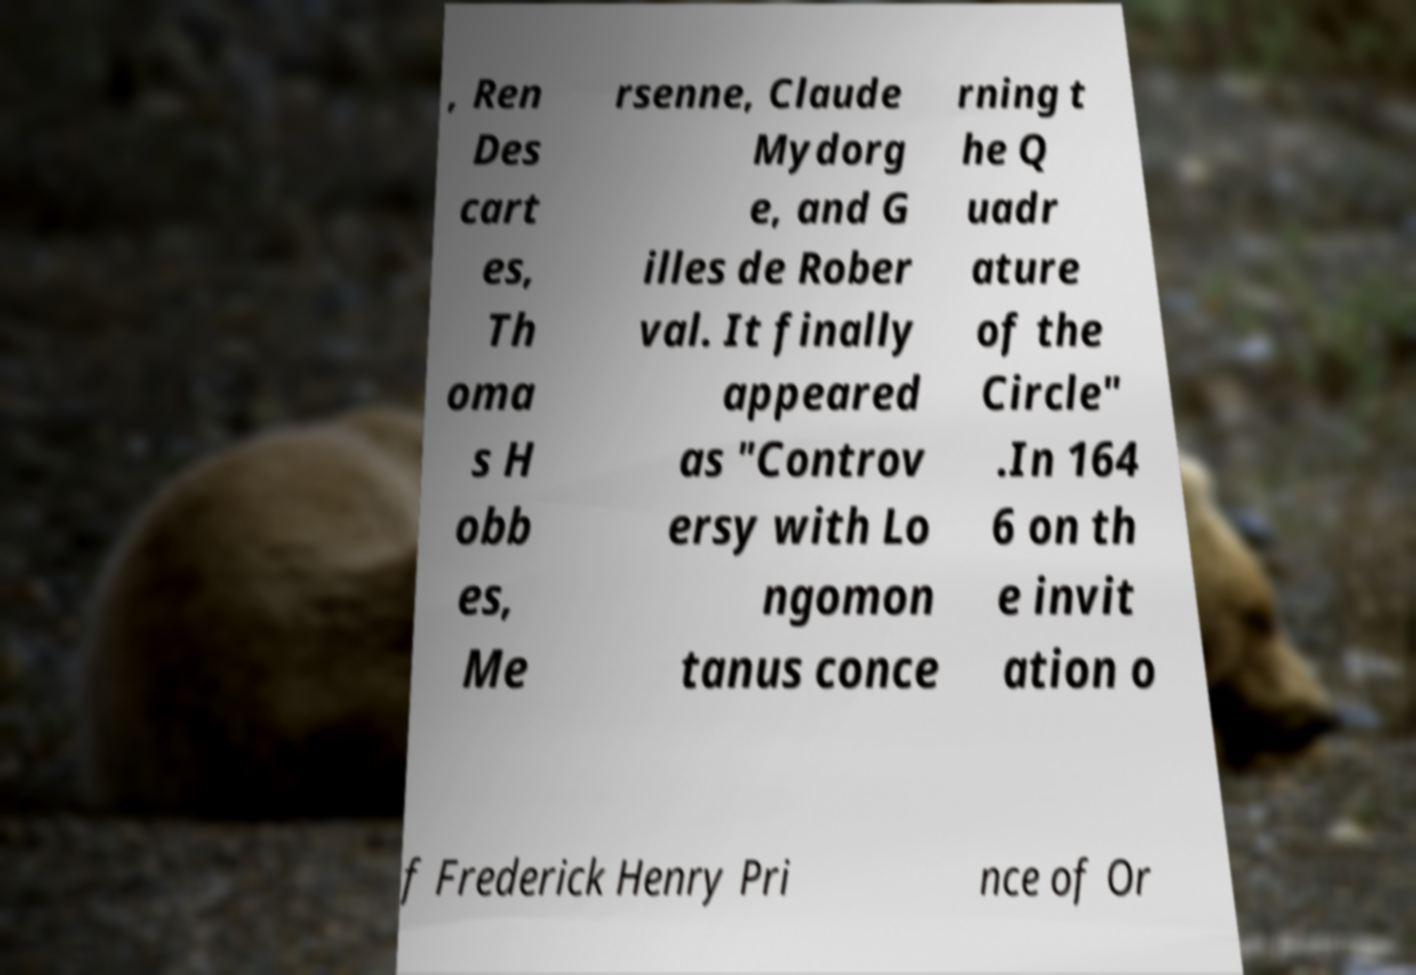Could you assist in decoding the text presented in this image and type it out clearly? , Ren Des cart es, Th oma s H obb es, Me rsenne, Claude Mydorg e, and G illes de Rober val. It finally appeared as "Controv ersy with Lo ngomon tanus conce rning t he Q uadr ature of the Circle" .In 164 6 on th e invit ation o f Frederick Henry Pri nce of Or 